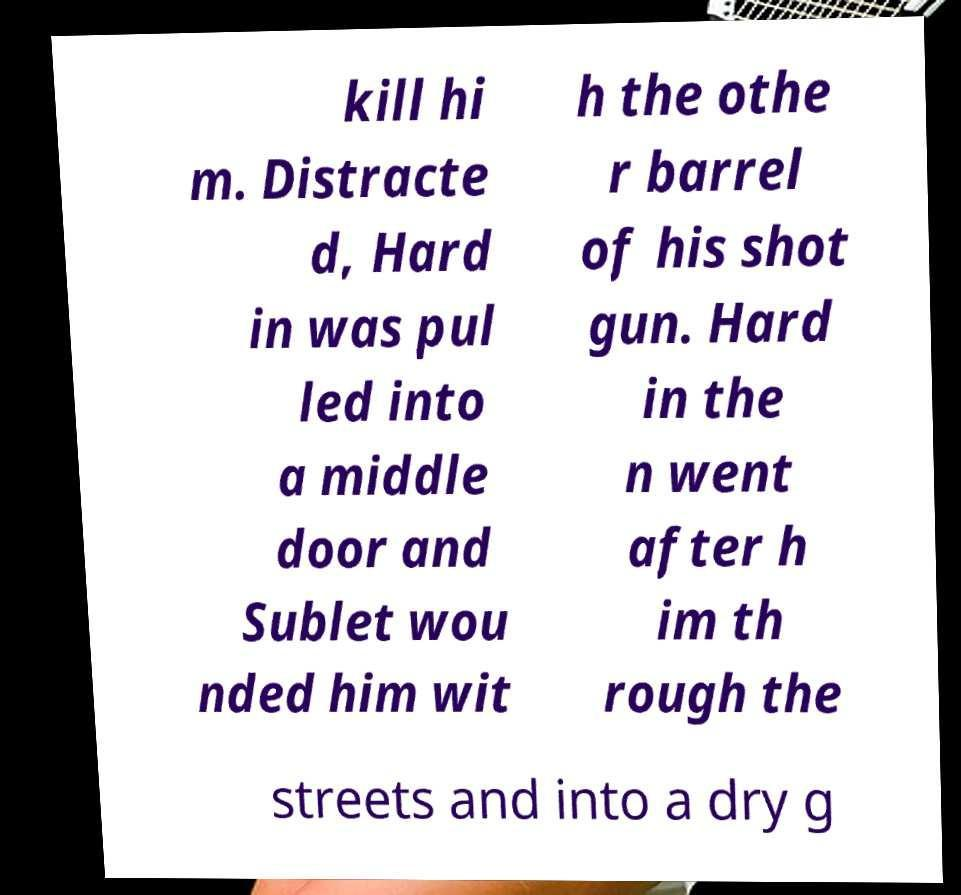Could you extract and type out the text from this image? kill hi m. Distracte d, Hard in was pul led into a middle door and Sublet wou nded him wit h the othe r barrel of his shot gun. Hard in the n went after h im th rough the streets and into a dry g 